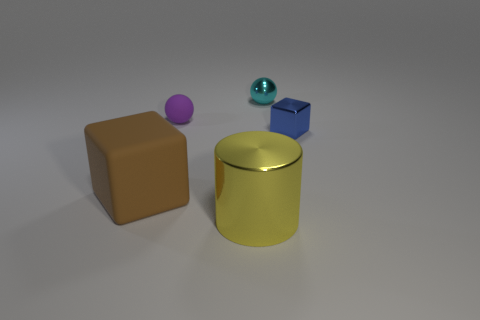What number of cylinders are brown things or big yellow shiny objects?
Offer a terse response. 1. There is a yellow cylinder; is its size the same as the matte object left of the small purple ball?
Offer a very short reply. Yes. Is the number of tiny balls that are behind the metallic cylinder greater than the number of large cyan rubber cylinders?
Your answer should be compact. Yes. The yellow cylinder that is the same material as the small blue object is what size?
Offer a terse response. Large. What number of objects are yellow things or objects that are to the left of the tiny cyan metal sphere?
Ensure brevity in your answer.  3. Is the number of blue shiny things greater than the number of big red objects?
Provide a short and direct response. Yes. Are there any yellow cylinders that have the same material as the tiny blue object?
Make the answer very short. Yes. The shiny object that is behind the large shiny thing and in front of the small cyan shiny ball has what shape?
Provide a short and direct response. Cube. What number of other things are the same shape as the small blue shiny object?
Keep it short and to the point. 1. What size is the purple rubber ball?
Your answer should be compact. Small. 